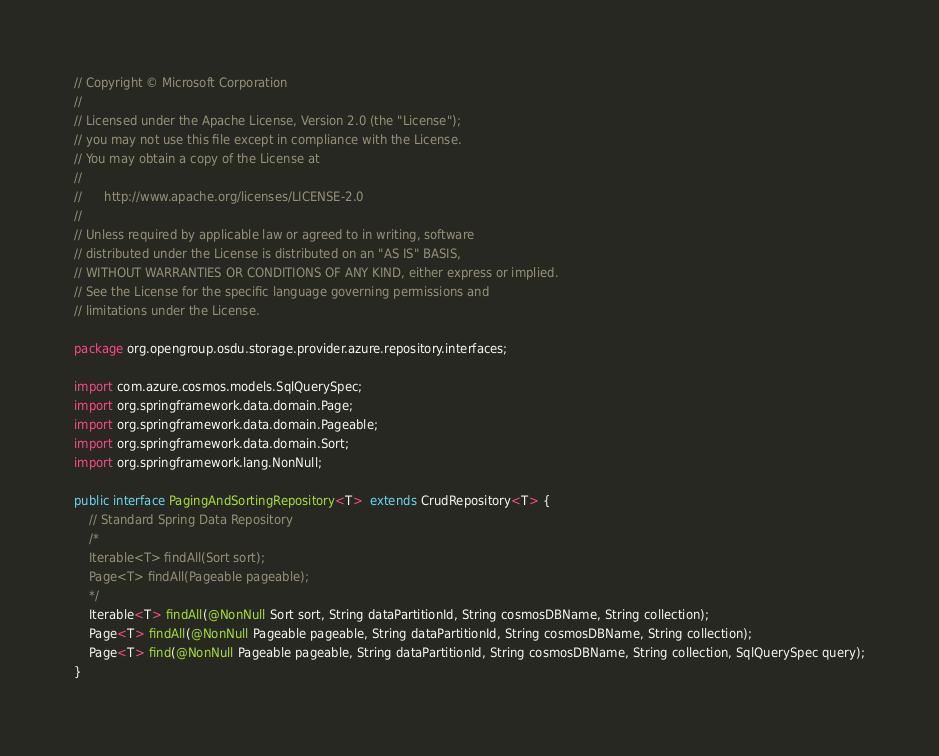Convert code to text. <code><loc_0><loc_0><loc_500><loc_500><_Java_>// Copyright © Microsoft Corporation
//
// Licensed under the Apache License, Version 2.0 (the "License");
// you may not use this file except in compliance with the License.
// You may obtain a copy of the License at
//
//      http://www.apache.org/licenses/LICENSE-2.0
//
// Unless required by applicable law or agreed to in writing, software
// distributed under the License is distributed on an "AS IS" BASIS,
// WITHOUT WARRANTIES OR CONDITIONS OF ANY KIND, either express or implied.
// See the License for the specific language governing permissions and
// limitations under the License.

package org.opengroup.osdu.storage.provider.azure.repository.interfaces;

import com.azure.cosmos.models.SqlQuerySpec;
import org.springframework.data.domain.Page;
import org.springframework.data.domain.Pageable;
import org.springframework.data.domain.Sort;
import org.springframework.lang.NonNull;

public interface PagingAndSortingRepository<T>  extends CrudRepository<T> {
    // Standard Spring Data Repository
    /*
    Iterable<T> findAll(Sort sort);
    Page<T> findAll(Pageable pageable);
    */
    Iterable<T> findAll(@NonNull Sort sort, String dataPartitionId, String cosmosDBName, String collection);
    Page<T> findAll(@NonNull Pageable pageable, String dataPartitionId, String cosmosDBName, String collection);
    Page<T> find(@NonNull Pageable pageable, String dataPartitionId, String cosmosDBName, String collection, SqlQuerySpec query);
}
</code> 